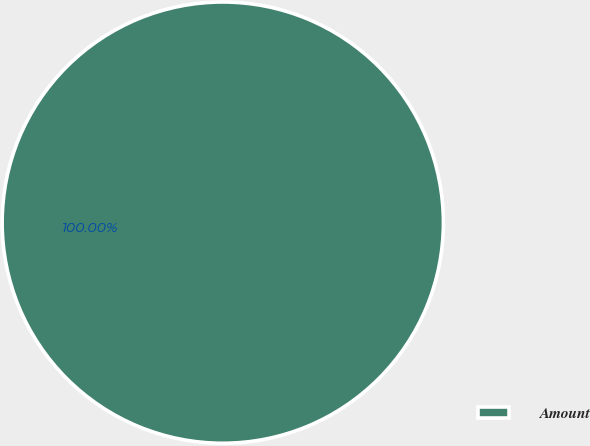Convert chart to OTSL. <chart><loc_0><loc_0><loc_500><loc_500><pie_chart><fcel>Amount<nl><fcel>100.0%<nl></chart> 